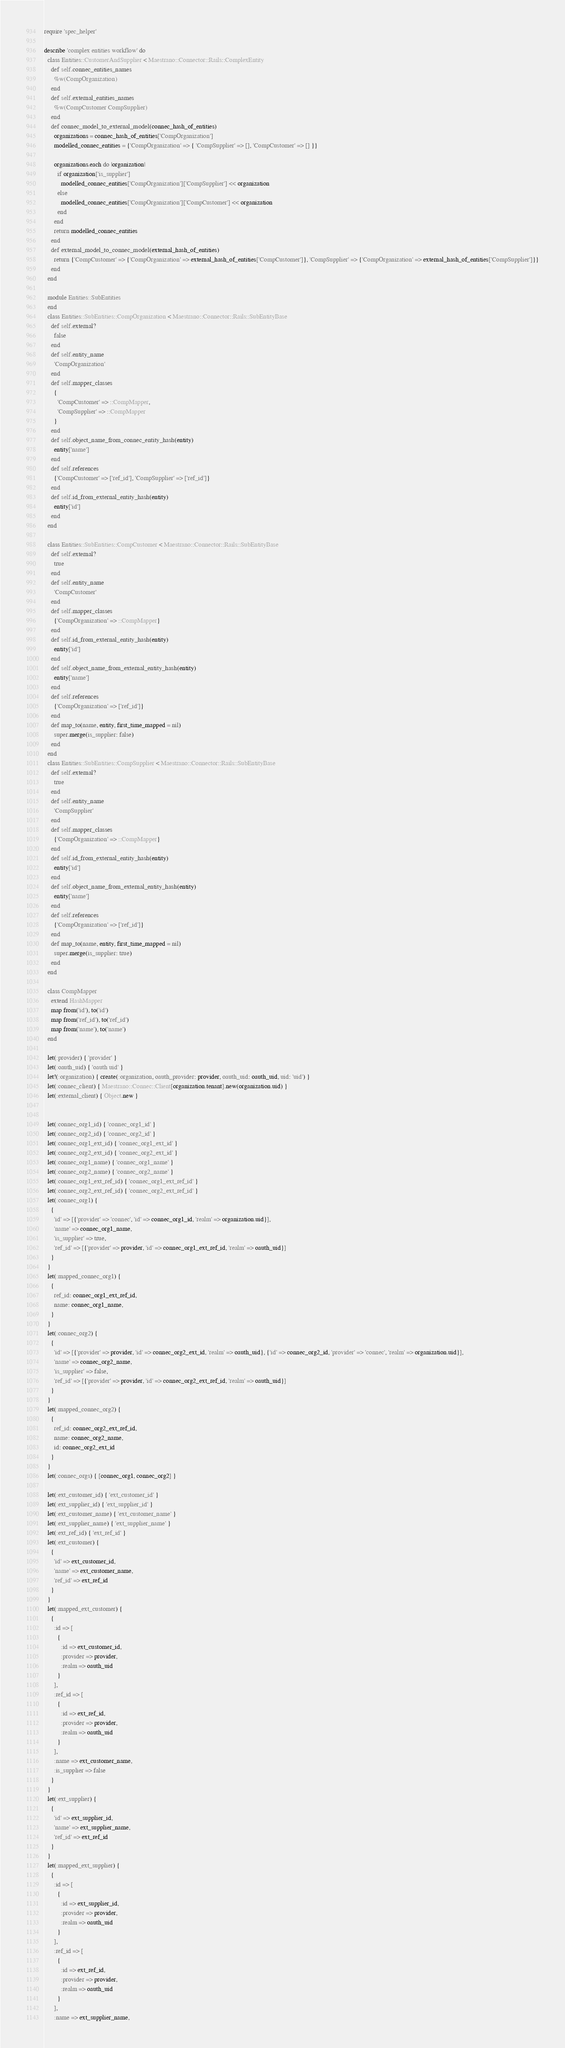Convert code to text. <code><loc_0><loc_0><loc_500><loc_500><_Ruby_>require 'spec_helper'

describe 'complex entities workflow' do
  class Entities::CustomerAndSupplier < Maestrano::Connector::Rails::ComplexEntity
    def self.connec_entities_names
      %w(CompOrganization)
    end
    def self.external_entities_names
      %w(CompCustomer CompSupplier)
    end
    def connec_model_to_external_model(connec_hash_of_entities)
      organizations = connec_hash_of_entities['CompOrganization']
      modelled_connec_entities = {'CompOrganization' => { 'CompSupplier' => [], 'CompCustomer' => [] }}

      organizations.each do |organization|
        if organization['is_supplier']
          modelled_connec_entities['CompOrganization']['CompSupplier'] << organization
        else
          modelled_connec_entities['CompOrganization']['CompCustomer'] << organization
        end
      end
      return modelled_connec_entities
    end
    def external_model_to_connec_model(external_hash_of_entities)
      return {'CompCustomer' => {'CompOrganization' => external_hash_of_entities['CompCustomer']}, 'CompSupplier' => {'CompOrganization' => external_hash_of_entities['CompSupplier']}}
    end
  end

  module Entities::SubEntities
  end
  class Entities::SubEntities::CompOrganization < Maestrano::Connector::Rails::SubEntityBase
    def self.external?
      false
    end
    def self.entity_name
      'CompOrganization'
    end
    def self.mapper_classes
      {
        'CompCustomer' => ::CompMapper,
        'CompSupplier' => ::CompMapper
      }
    end
    def self.object_name_from_connec_entity_hash(entity)
      entity['name']
    end
    def self.references
      {'CompCustomer' => ['ref_id'], 'CompSupplier' => ['ref_id']}
    end
    def self.id_from_external_entity_hash(entity)
      entity['id']
    end
  end

  class Entities::SubEntities::CompCustomer < Maestrano::Connector::Rails::SubEntityBase
    def self.external?
      true
    end
    def self.entity_name
      'CompCustomer'
    end
    def self.mapper_classes
      {'CompOrganization' => ::CompMapper}
    end
    def self.id_from_external_entity_hash(entity)
      entity['id']
    end
    def self.object_name_from_external_entity_hash(entity)
      entity['name']
    end
    def self.references
      {'CompOrganization' => ['ref_id']}
    end
    def map_to(name, entity, first_time_mapped = nil)
      super.merge(is_supplier: false)
    end
  end
  class Entities::SubEntities::CompSupplier < Maestrano::Connector::Rails::SubEntityBase
    def self.external?
      true
    end
    def self.entity_name
      'CompSupplier'
    end
    def self.mapper_classes
      {'CompOrganization' => ::CompMapper}
    end
    def self.id_from_external_entity_hash(entity)
      entity['id']
    end
    def self.object_name_from_external_entity_hash(entity)
      entity['name']
    end
    def self.references
      {'CompOrganization' => ['ref_id']}
    end
    def map_to(name, entity, first_time_mapped = nil)
      super.merge(is_supplier: true)
    end
  end

  class CompMapper
    extend HashMapper
    map from('id'), to('id')
    map from('ref_id'), to('ref_id')
    map from('name'), to('name')
  end

  let(:provider) { 'provider' }
  let(:oauth_uid) { 'oauth uid' }
  let!(:organization) { create(:organization, oauth_provider: provider, oauth_uid: oauth_uid, uid: 'uid') }
  let(:connec_client) { Maestrano::Connec::Client[organization.tenant].new(organization.uid) }
  let(:external_client) { Object.new }


  let(:connec_org1_id) { 'connec_org1_id' }
  let(:connec_org2_id) { 'connec_org2_id' }
  let(:connec_org1_ext_id) { 'connec_org1_ext_id' }
  let(:connec_org2_ext_id) { 'connec_org2_ext_id' }
  let(:connec_org1_name) { 'connec_org1_name' }
  let(:connec_org2_name) { 'connec_org2_name' }
  let(:connec_org1_ext_ref_id) { 'connec_org1_ext_ref_id' }
  let(:connec_org2_ext_ref_id) { 'connec_org2_ext_ref_id' }
  let(:connec_org1) {
    {
      'id' => [{'provider' => 'connec', 'id' => connec_org1_id, 'realm' => organization.uid}],
      'name' => connec_org1_name,
      'is_supplier' => true,
      'ref_id' => [{'provider' => provider, 'id' => connec_org1_ext_ref_id, 'realm' => oauth_uid}]
    }
  }
  let(:mapped_connec_org1) {
    {
      ref_id: connec_org1_ext_ref_id,
      name: connec_org1_name,
    }
  }
  let(:connec_org2) {
    {
      'id' => [{'provider' => provider, 'id' => connec_org2_ext_id, 'realm' => oauth_uid}, {'id' => connec_org2_id, 'provider' => 'connec', 'realm' => organization.uid}],
      'name' => connec_org2_name,
      'is_supplier' => false,
      'ref_id' => [{'provider' => provider, 'id' => connec_org2_ext_ref_id, 'realm' => oauth_uid}]
    }
  }
  let(:mapped_connec_org2) {
    {
      ref_id: connec_org2_ext_ref_id,
      name: connec_org2_name,
      id: connec_org2_ext_id
    }
  }
  let(:connec_orgs) { [connec_org1, connec_org2] }

  let(:ext_customer_id) { 'ext_customer_id' }
  let(:ext_supplier_id) { 'ext_supplier_id' }
  let(:ext_customer_name) { 'ext_customer_name' }
  let(:ext_supplier_name) { 'ext_supplier_name' }
  let(:ext_ref_id) { 'ext_ref_id' }
  let(:ext_customer) {
    {
      'id' => ext_customer_id,
      'name' => ext_customer_name,
      'ref_id' => ext_ref_id
    }
  }
  let(:mapped_ext_customer) {
    {
      :id => [
        {
          :id => ext_customer_id,
          :provider => provider,
          :realm => oauth_uid
        }
      ],
      :ref_id => [
        {
          :id => ext_ref_id,
          :provider => provider,
          :realm => oauth_uid
        }
      ],
      :name => ext_customer_name,
      :is_supplier => false
    }
  }
  let(:ext_supplier) {
    {
      'id' => ext_supplier_id,
      'name' => ext_supplier_name,
      'ref_id' => ext_ref_id
    }
  }
  let(:mapped_ext_supplier) {
    {
      :id => [
        {
          :id => ext_supplier_id,
          :provider => provider,
          :realm => oauth_uid
        }
      ],
      :ref_id => [
        {
          :id => ext_ref_id,
          :provider => provider,
          :realm => oauth_uid
        }
      ],
      :name => ext_supplier_name,</code> 